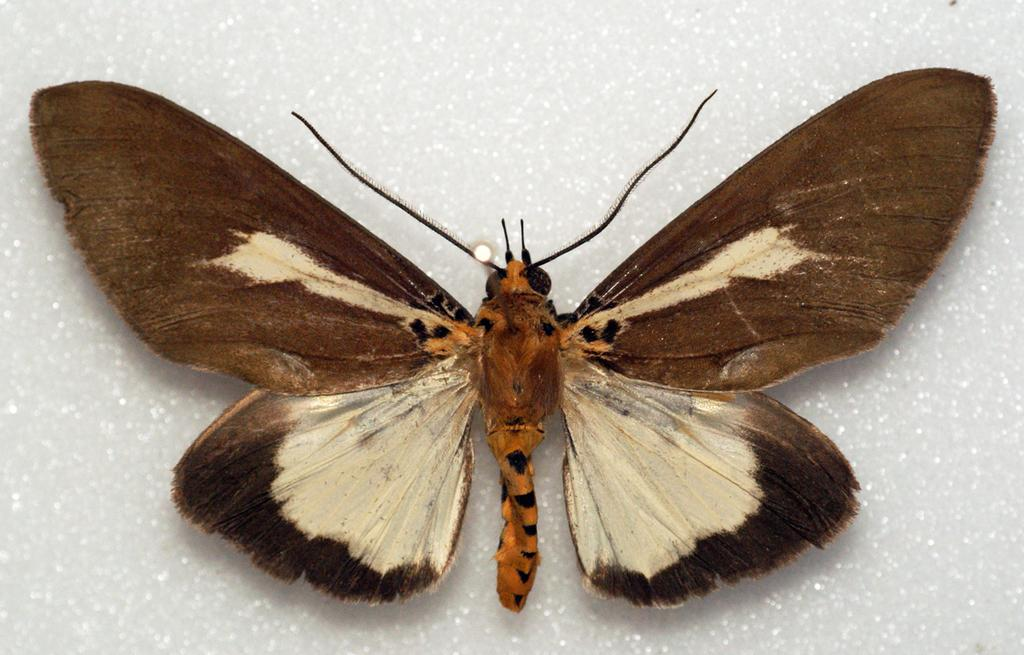What is the main subject of the image? There is a butterfly in the image. What is the color of the surface on which the butterfly is resting? The butterfly is on a white surface. What type of cannon is present in the image? There is no cannon present in the image; it features a butterfly on a white surface. How does the zephyr affect the butterfly in the image? There is no mention of a zephyr or any wind in the image, so it cannot be determined how it might affect the butterfly. 